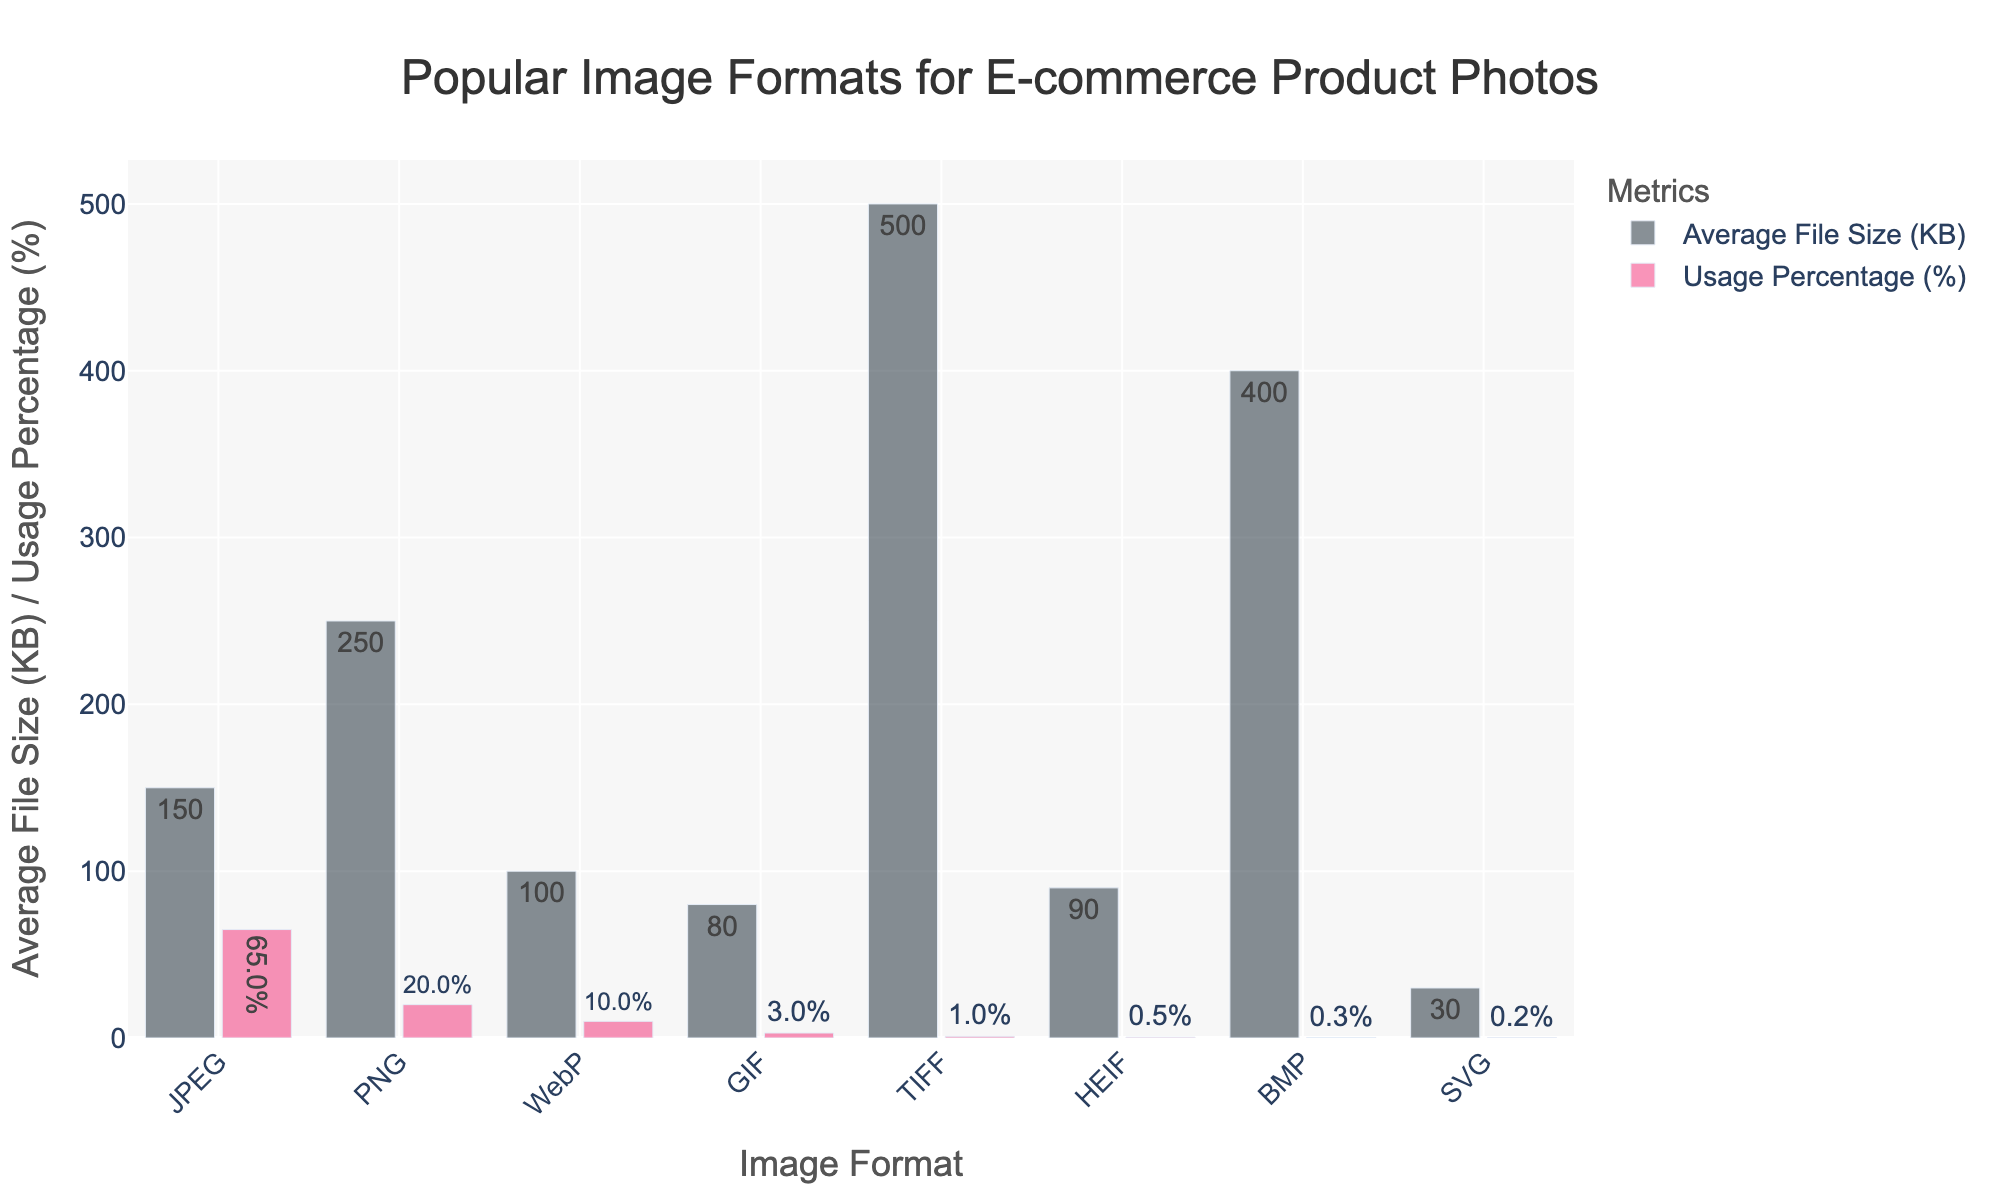Which image format has the smallest average file size? Looking at the height of the bars representing 'Average File Size (KB)', the SVG format has the smallest average file size.
Answer: SVG Which two image formats have the highest average file sizes? Reviewing the heights of the bars for 'Average File Size (KB)', the TIFF and BMP formats have the highest average file sizes.
Answer: TIFF and BMP What is the combined usage percentage of JPEG and PNG formats? The usage percentage of JPEG is 65% and PNG is 20%. Adding them together, 65 + 20 = 85%.
Answer: 85% Which image format has the highest usage percentage and what is its average file size? The format with the highest usage percentage is JPEG at 65%, and its corresponding average file size is 150 KB.
Answer: JPEG and 150 KB Compare the average file sizes of GIF and HEIF formats. The average file size of GIF is 80 KB, while that of HEIF is 90 KB. Comparing these, GIF has a smaller average file size than HEIF.
Answer: GIF has a smaller file size By how much does the average file size of BMP exceed that of WebP? The average file size of BMP is 400 KB, while WebP is 100 KB. The difference between them is 400 - 100 = 300 KB.
Answer: 300 KB What percentage of formats have an average file size of less than 100 KB? The formats with average file sizes less than 100 KB are GIF (80 KB), HEIF (90 KB), and SVG (30 KB), making 3 out of 8 formats. Calculating the percentage, (3/8) * 100 = 37.5%.
Answer: 37.5% What are the colors representing 'Average File Size (KB)' and 'Usage Percentage (%)' in the figure? The bar for 'Average File Size (KB)' is shaded dark gray, while the bar for 'Usage Percentage (%)' is shaded pink.
Answer: dark gray and pink 